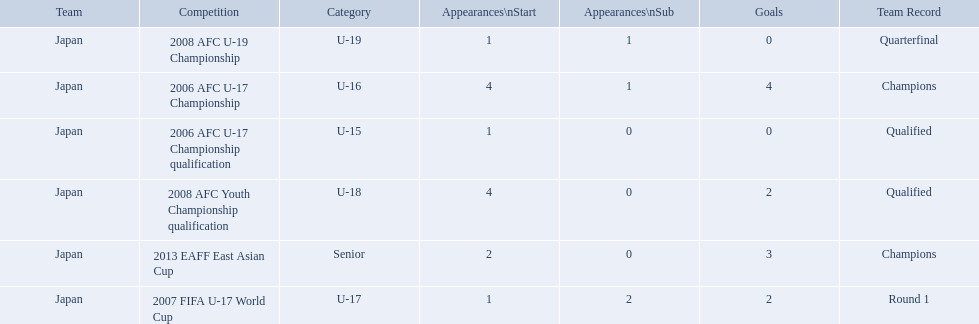How many appearances were there for each competition? 1, 4, 1, 4, 1, 2. How many goals were there for each competition? 0, 4, 2, 2, 0, 3. Which competition(s) has/have the most appearances? 2006 AFC U-17 Championship, 2008 AFC Youth Championship qualification. Which competition(s) has/have the most goals? 2006 AFC U-17 Championship. 